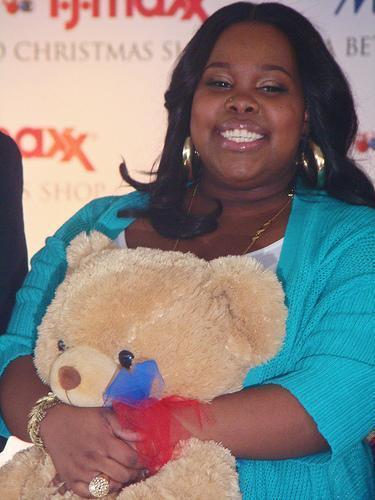How many earrings does she have?
Give a very brief answer. 2. 